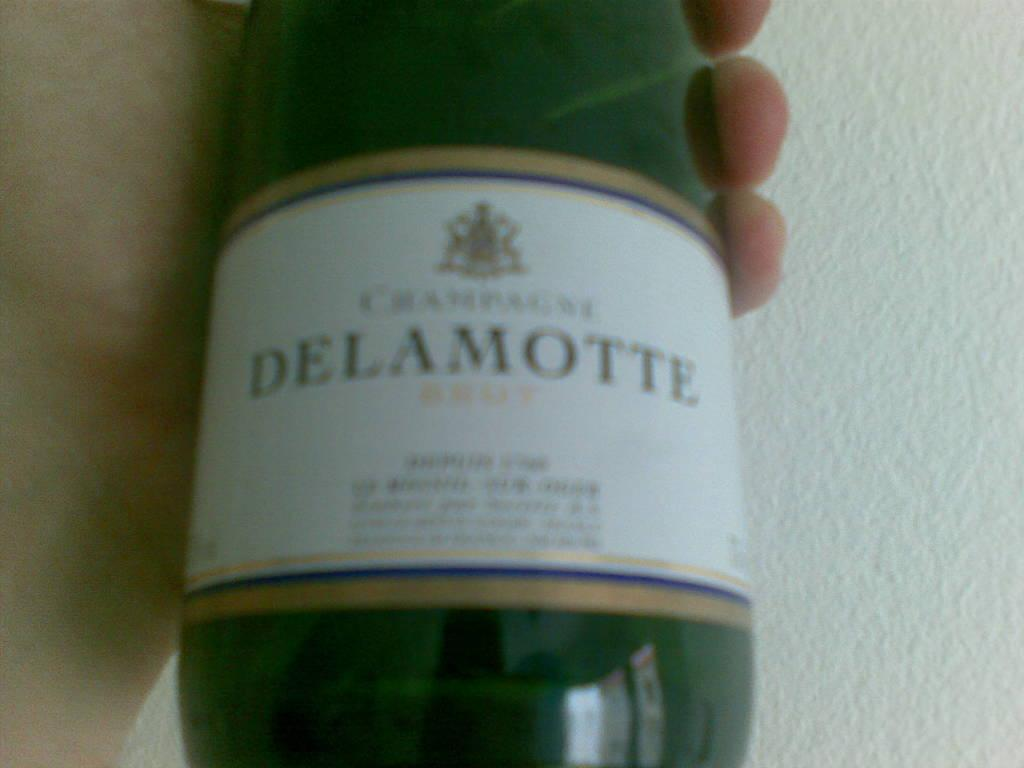<image>
Create a compact narrative representing the image presented. A hand is holding up a green bottle of Delamotte champagne. 